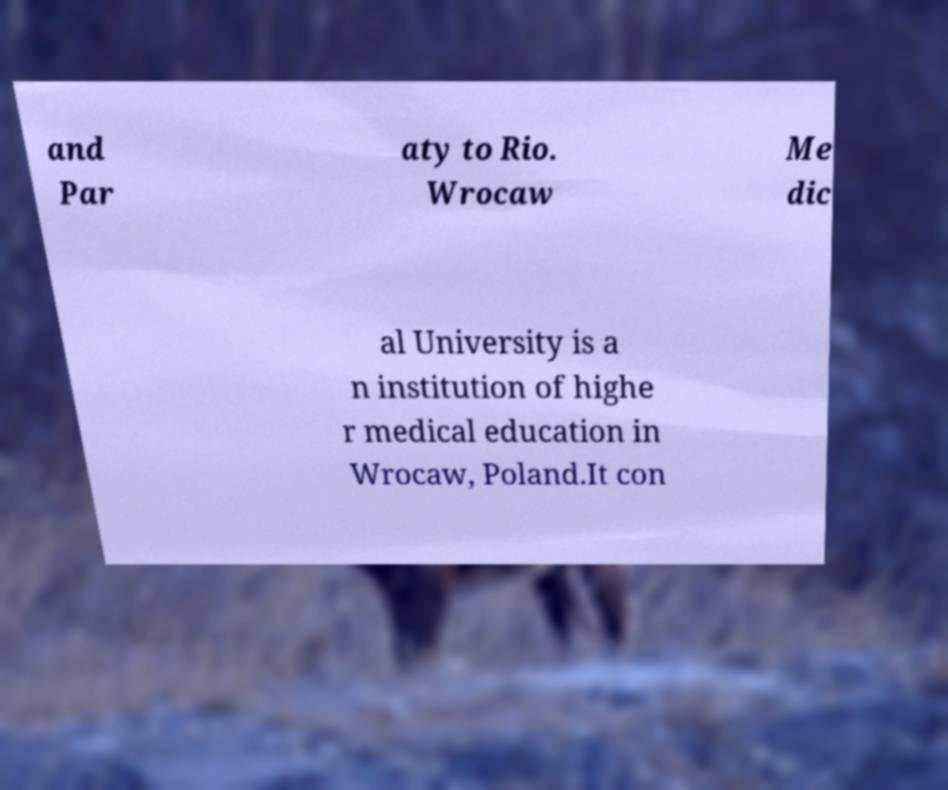What messages or text are displayed in this image? I need them in a readable, typed format. and Par aty to Rio. Wrocaw Me dic al University is a n institution of highe r medical education in Wrocaw, Poland.It con 